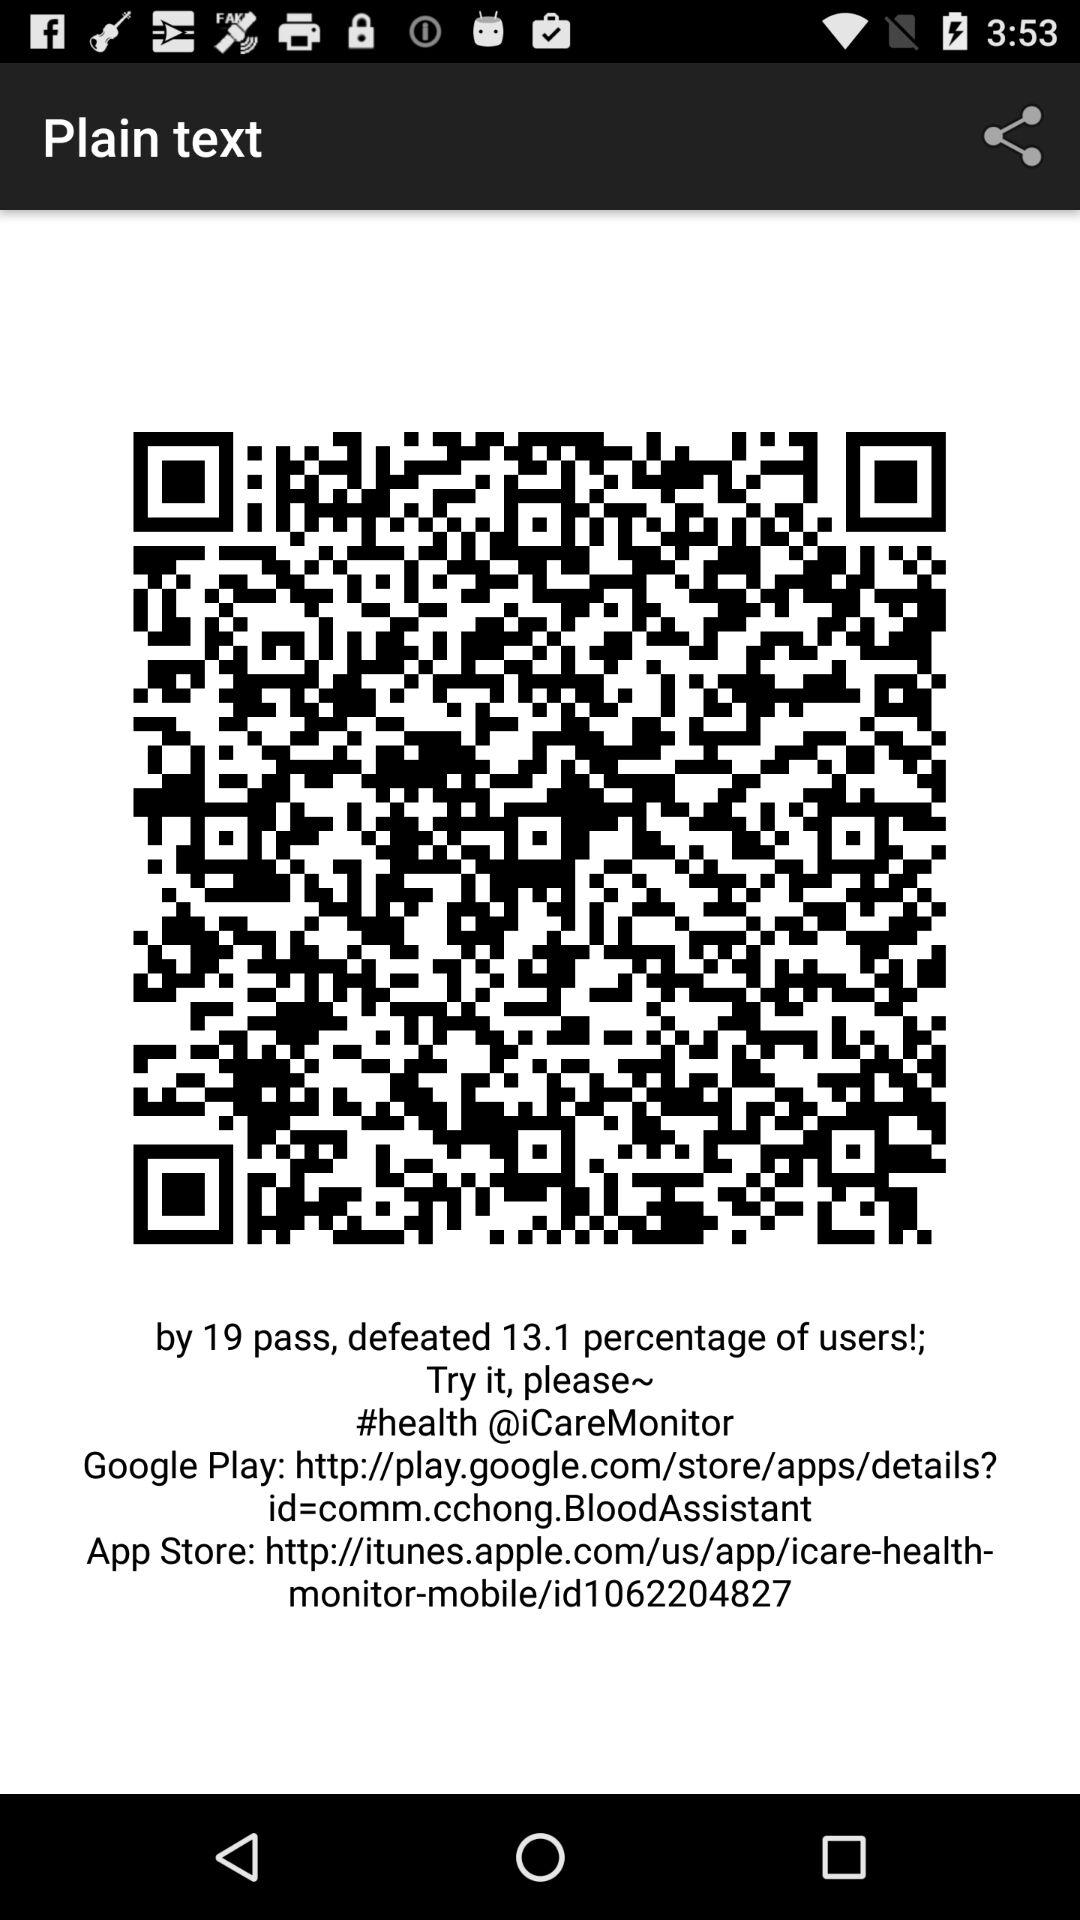What is the Google Play web link? The Google Play web link is http://play.google.com/store/apps/details?id=comm.cchong.BloodAssistant. 